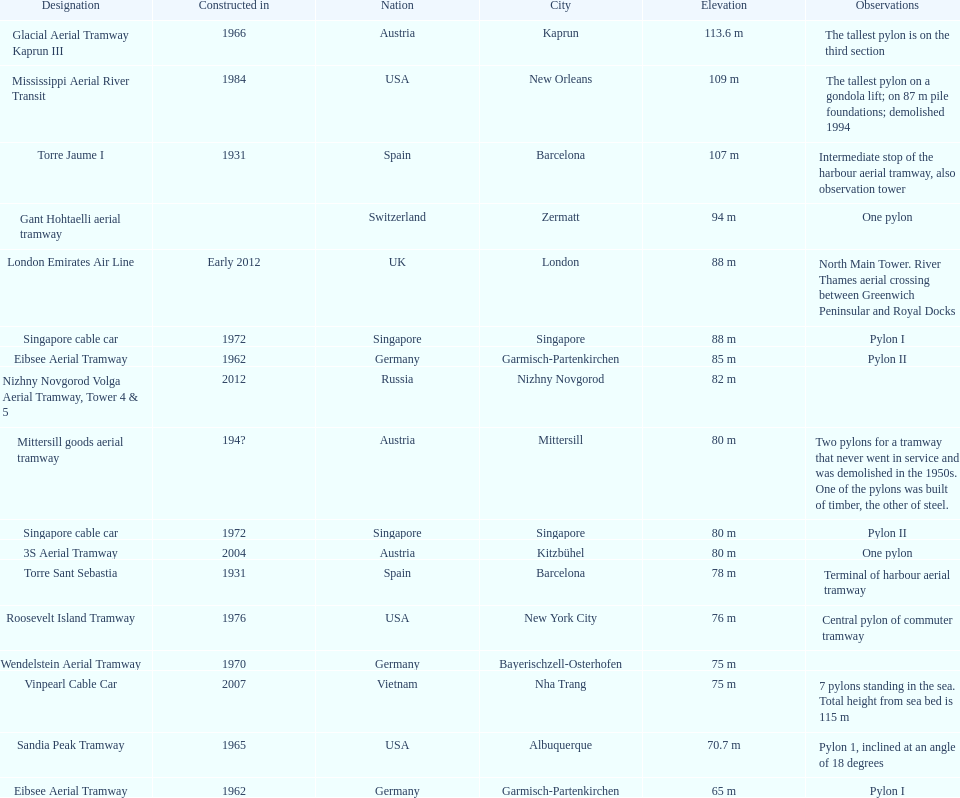How many pylons are in austria? 3. 